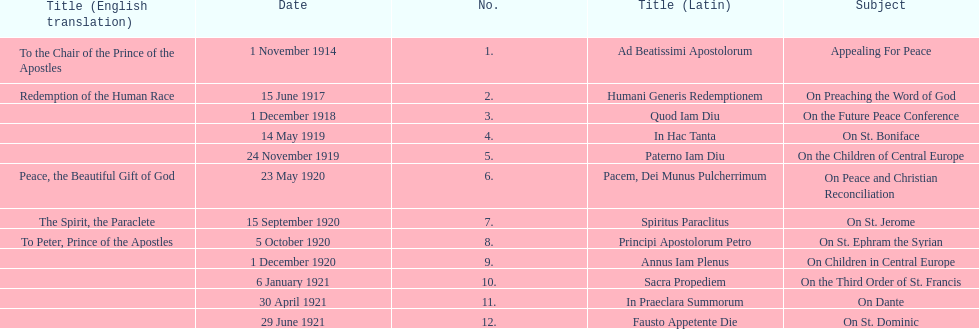After 1 december 1918 when was the next encyclical? 14 May 1919. 